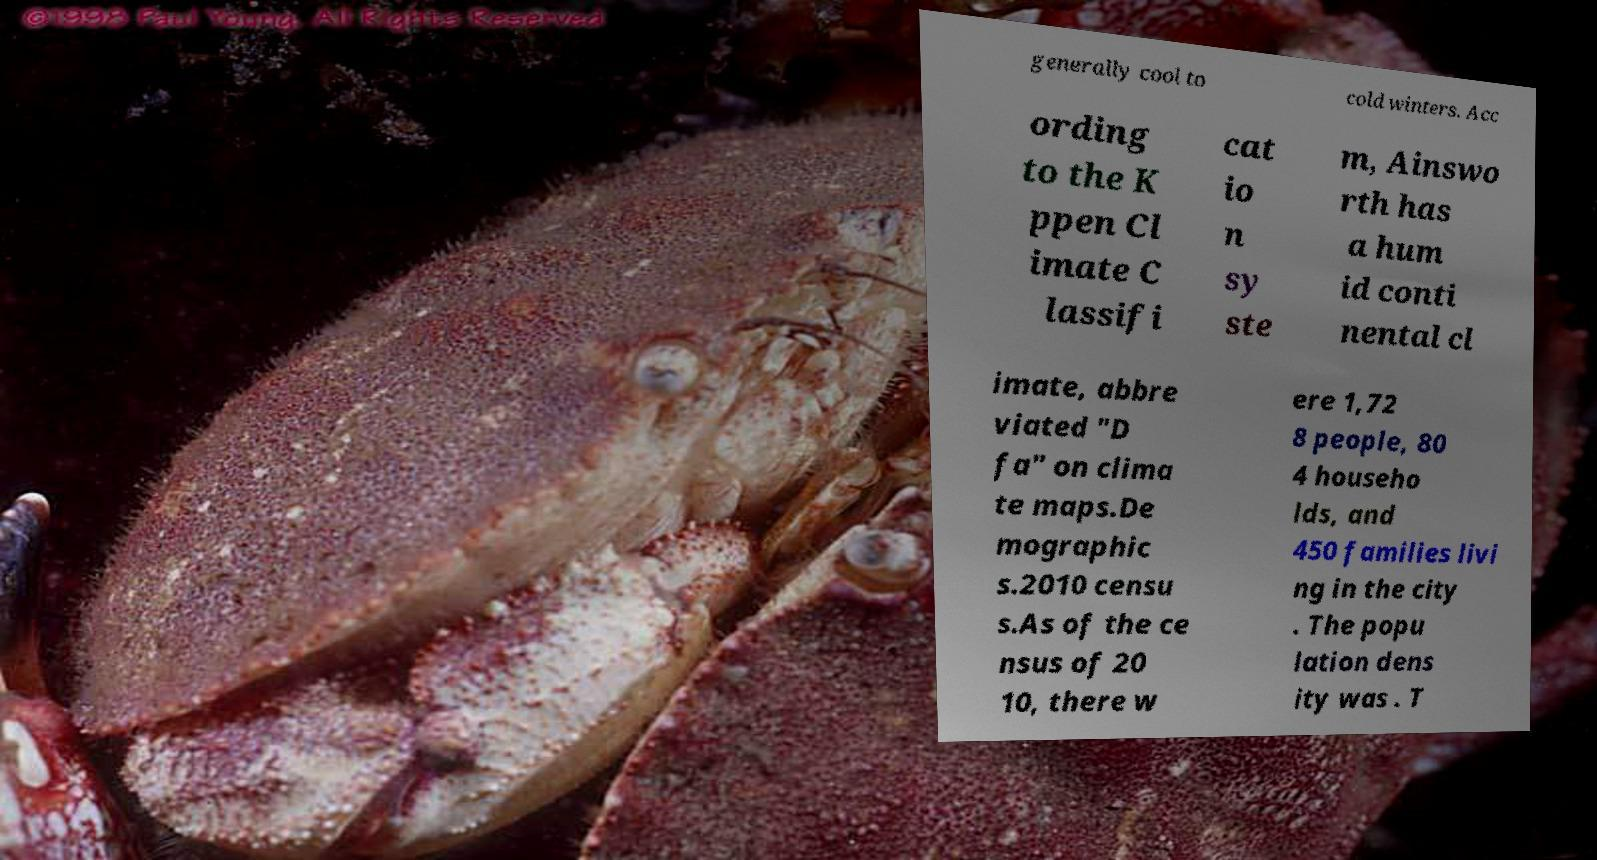There's text embedded in this image that I need extracted. Can you transcribe it verbatim? generally cool to cold winters. Acc ording to the K ppen Cl imate C lassifi cat io n sy ste m, Ainswo rth has a hum id conti nental cl imate, abbre viated "D fa" on clima te maps.De mographic s.2010 censu s.As of the ce nsus of 20 10, there w ere 1,72 8 people, 80 4 househo lds, and 450 families livi ng in the city . The popu lation dens ity was . T 